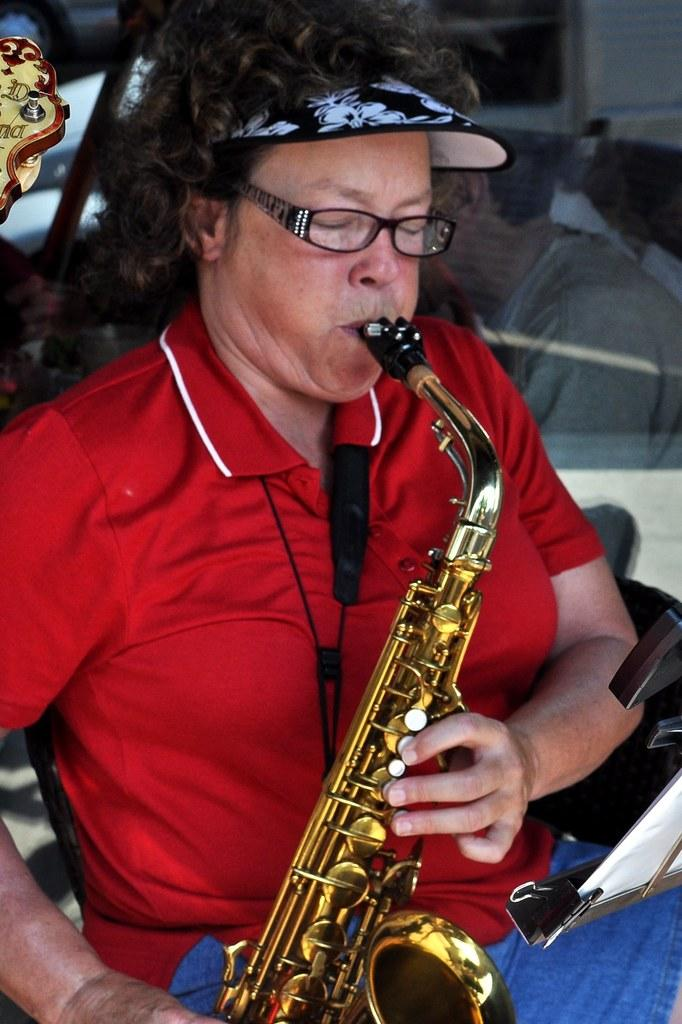What is the main subject of the image? There is a person in the image. What is the person doing in the image? The person is playing a trumpet. What type of cast can be seen on the person's arm in the image? There is no cast visible on the person's arm in the image. How is the meal being divided among the people in the image? There is no meal or division of a meal present in the image; it only features a person playing a trumpet. 